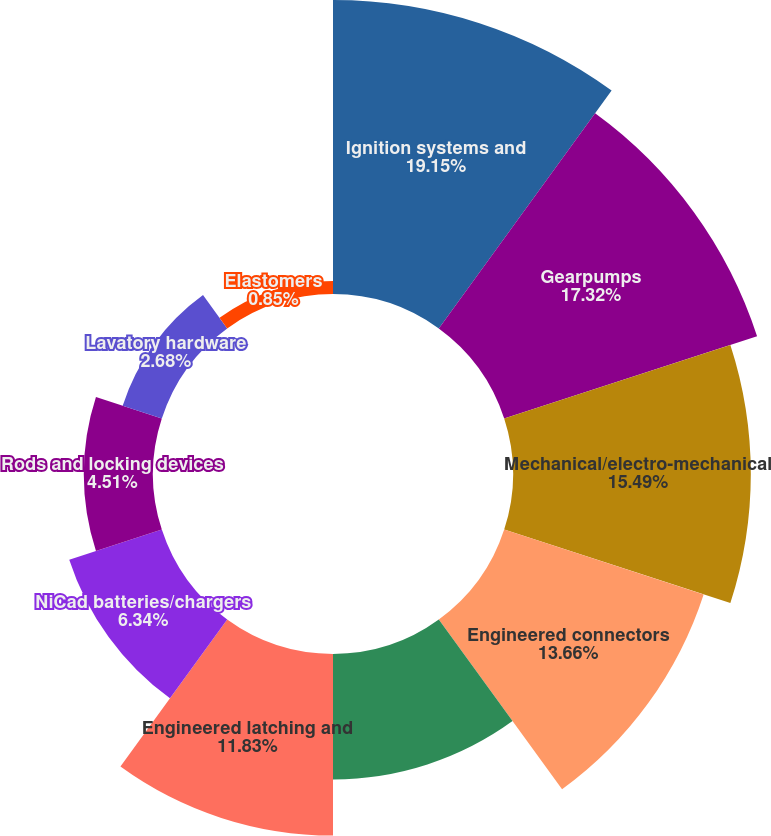Convert chart. <chart><loc_0><loc_0><loc_500><loc_500><pie_chart><fcel>Ignition systems and<fcel>Gearpumps<fcel>Mechanical/electro-mechanical<fcel>Engineered connectors<fcel>Specialized valves<fcel>Engineered latching and<fcel>NiCad batteries/chargers<fcel>Rods and locking devices<fcel>Lavatory hardware<fcel>Elastomers<nl><fcel>19.15%<fcel>17.32%<fcel>15.49%<fcel>13.66%<fcel>8.17%<fcel>11.83%<fcel>6.34%<fcel>4.51%<fcel>2.68%<fcel>0.85%<nl></chart> 